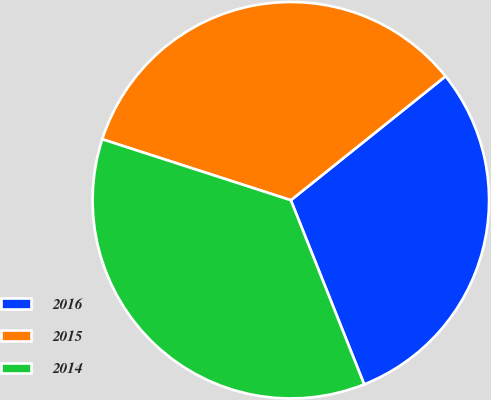Convert chart. <chart><loc_0><loc_0><loc_500><loc_500><pie_chart><fcel>2016<fcel>2015<fcel>2014<nl><fcel>29.72%<fcel>34.27%<fcel>36.01%<nl></chart> 